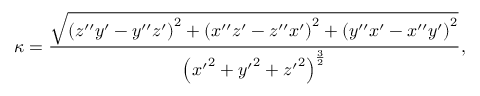<formula> <loc_0><loc_0><loc_500><loc_500>\kappa = { \frac { \sqrt { \left ( z ^ { \prime \prime } y ^ { \prime } - y ^ { \prime \prime } z ^ { \prime } \right ) ^ { 2 } + \left ( x ^ { \prime \prime } z ^ { \prime } - z ^ { \prime \prime } x ^ { \prime } \right ) ^ { 2 } + \left ( y ^ { \prime \prime } x ^ { \prime } - x ^ { \prime \prime } y ^ { \prime } \right ) ^ { 2 } } } { \left ( { x ^ { \prime } } ^ { 2 } + { y ^ { \prime } } ^ { 2 } + { z ^ { \prime } } ^ { 2 } \right ) ^ { \frac { 3 } { 2 } } } } ,</formula> 